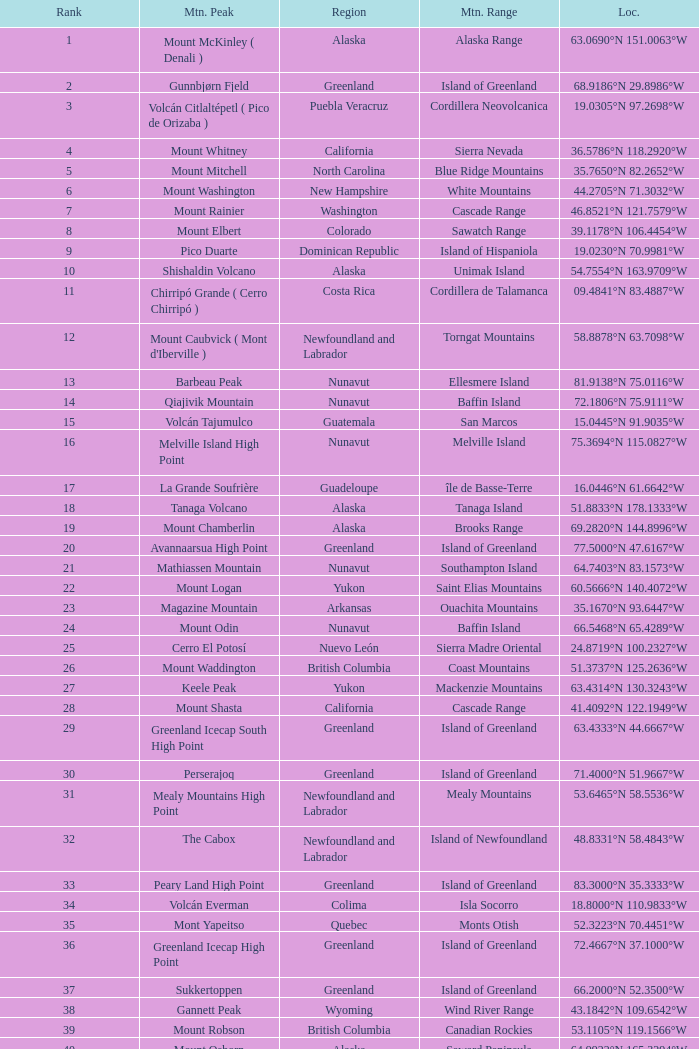Which peak, located at 28.1301°n 115.2206°w, belongs to the baja california region? Isla Cedros High Point. 